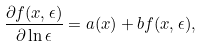<formula> <loc_0><loc_0><loc_500><loc_500>\frac { \partial f ( x , \epsilon ) } { \partial \ln \epsilon } = a ( x ) + b f ( x , \epsilon ) ,</formula> 